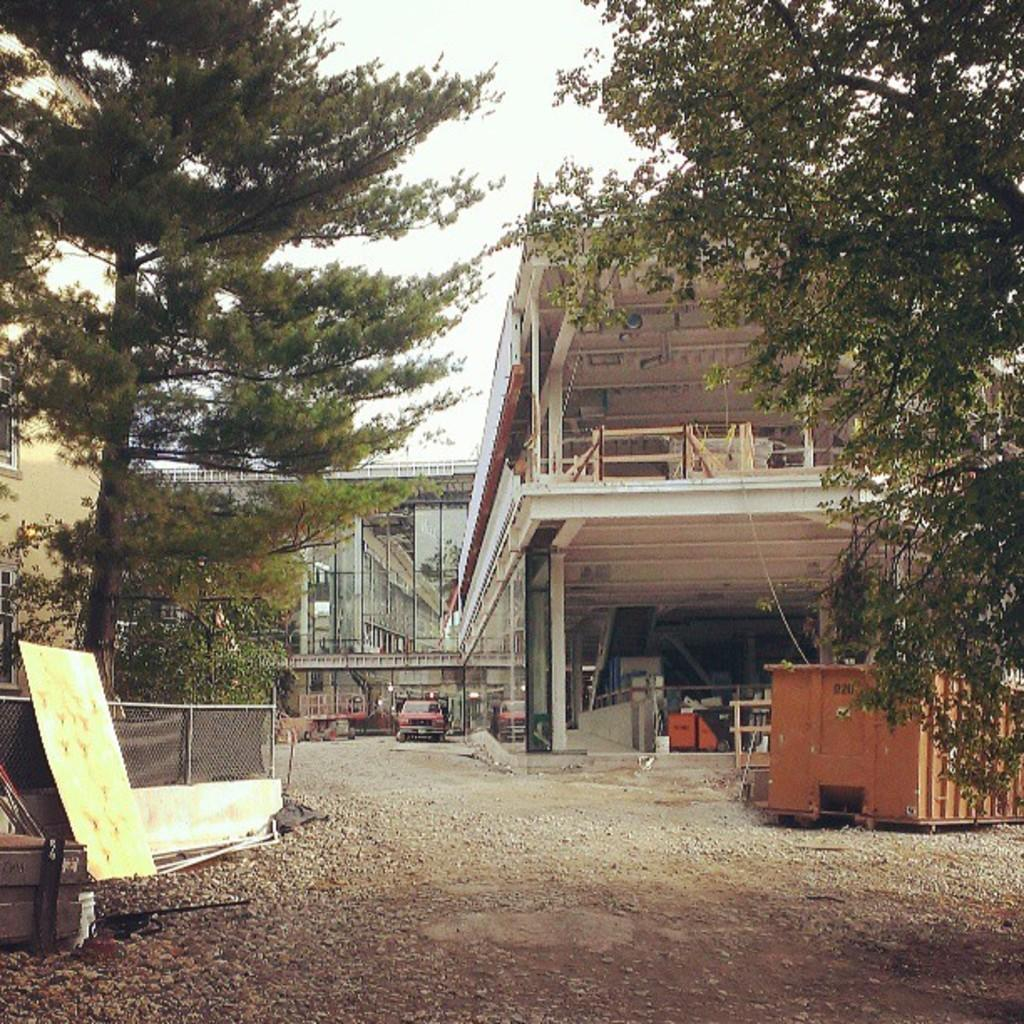What type of natural elements can be seen in the image? There are trees in the image. What type of man-made structures are present in the image? There are buildings in the image. What type of barrier can be seen in the image? There is a fence in the image. What type of transportation is visible in the image? There is a vehicle in the image. What part of the natural environment is visible in the image? The sky is visible in the image. What color is the tongue of the person in the image? There is no person present in the image, so there is no tongue to observe. What type of notebook is being used by the person in the image? There is no person present in the image, so there is no notebook being used. 